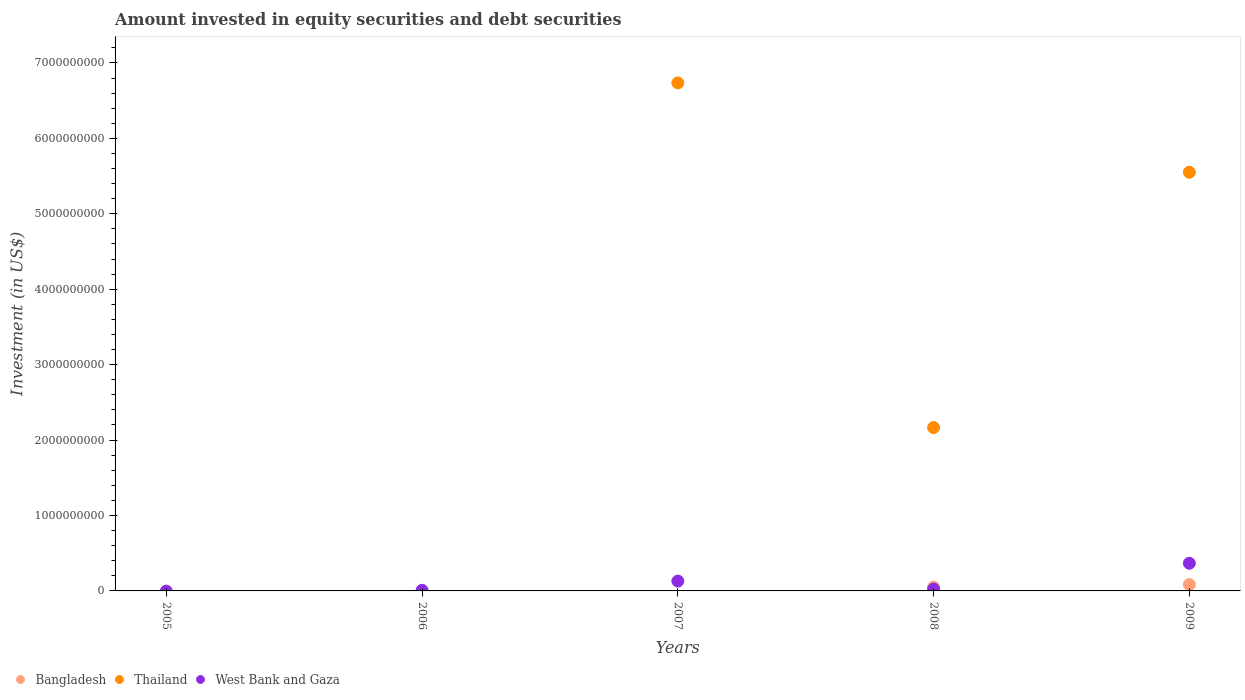How many different coloured dotlines are there?
Offer a terse response. 3. Is the number of dotlines equal to the number of legend labels?
Your answer should be compact. No. What is the amount invested in equity securities and debt securities in West Bank and Gaza in 2006?
Provide a succinct answer. 8.38e+06. Across all years, what is the maximum amount invested in equity securities and debt securities in Thailand?
Your answer should be very brief. 6.74e+09. What is the total amount invested in equity securities and debt securities in Bangladesh in the graph?
Your answer should be compact. 1.35e+08. What is the difference between the amount invested in equity securities and debt securities in Thailand in 2008 and that in 2009?
Your answer should be very brief. -3.39e+09. What is the difference between the amount invested in equity securities and debt securities in Bangladesh in 2005 and the amount invested in equity securities and debt securities in Thailand in 2008?
Ensure brevity in your answer.  -2.17e+09. What is the average amount invested in equity securities and debt securities in Bangladesh per year?
Provide a succinct answer. 2.71e+07. In the year 2008, what is the difference between the amount invested in equity securities and debt securities in West Bank and Gaza and amount invested in equity securities and debt securities in Bangladesh?
Offer a terse response. -2.59e+07. In how many years, is the amount invested in equity securities and debt securities in Bangladesh greater than 6000000000 US$?
Give a very brief answer. 0. What is the ratio of the amount invested in equity securities and debt securities in West Bank and Gaza in 2008 to that in 2009?
Your answer should be compact. 0.07. What is the difference between the highest and the second highest amount invested in equity securities and debt securities in Thailand?
Ensure brevity in your answer.  1.19e+09. What is the difference between the highest and the lowest amount invested in equity securities and debt securities in West Bank and Gaza?
Your answer should be very brief. 3.67e+08. In how many years, is the amount invested in equity securities and debt securities in West Bank and Gaza greater than the average amount invested in equity securities and debt securities in West Bank and Gaza taken over all years?
Provide a succinct answer. 2. Is it the case that in every year, the sum of the amount invested in equity securities and debt securities in Thailand and amount invested in equity securities and debt securities in West Bank and Gaza  is greater than the amount invested in equity securities and debt securities in Bangladesh?
Your answer should be very brief. No. How many dotlines are there?
Provide a succinct answer. 3. How many years are there in the graph?
Offer a very short reply. 5. Does the graph contain any zero values?
Give a very brief answer. Yes. Where does the legend appear in the graph?
Your response must be concise. Bottom left. How many legend labels are there?
Provide a short and direct response. 3. What is the title of the graph?
Make the answer very short. Amount invested in equity securities and debt securities. What is the label or title of the Y-axis?
Ensure brevity in your answer.  Investment (in US$). What is the Investment (in US$) in West Bank and Gaza in 2005?
Your answer should be compact. 0. What is the Investment (in US$) in Bangladesh in 2006?
Make the answer very short. 0. What is the Investment (in US$) in Thailand in 2006?
Your response must be concise. 0. What is the Investment (in US$) of West Bank and Gaza in 2006?
Your answer should be compact. 8.38e+06. What is the Investment (in US$) of Thailand in 2007?
Your response must be concise. 6.74e+09. What is the Investment (in US$) in West Bank and Gaza in 2007?
Offer a terse response. 1.31e+08. What is the Investment (in US$) of Bangladesh in 2008?
Your answer should be very brief. 5.06e+07. What is the Investment (in US$) of Thailand in 2008?
Provide a succinct answer. 2.17e+09. What is the Investment (in US$) in West Bank and Gaza in 2008?
Your response must be concise. 2.47e+07. What is the Investment (in US$) in Bangladesh in 2009?
Your answer should be compact. 8.47e+07. What is the Investment (in US$) in Thailand in 2009?
Provide a succinct answer. 5.55e+09. What is the Investment (in US$) of West Bank and Gaza in 2009?
Give a very brief answer. 3.67e+08. Across all years, what is the maximum Investment (in US$) of Bangladesh?
Offer a terse response. 8.47e+07. Across all years, what is the maximum Investment (in US$) in Thailand?
Provide a succinct answer. 6.74e+09. Across all years, what is the maximum Investment (in US$) in West Bank and Gaza?
Your response must be concise. 3.67e+08. Across all years, what is the minimum Investment (in US$) in Bangladesh?
Your answer should be very brief. 0. What is the total Investment (in US$) of Bangladesh in the graph?
Ensure brevity in your answer.  1.35e+08. What is the total Investment (in US$) in Thailand in the graph?
Give a very brief answer. 1.45e+1. What is the total Investment (in US$) of West Bank and Gaza in the graph?
Offer a very short reply. 5.31e+08. What is the difference between the Investment (in US$) in West Bank and Gaza in 2006 and that in 2007?
Give a very brief answer. -1.22e+08. What is the difference between the Investment (in US$) in West Bank and Gaza in 2006 and that in 2008?
Offer a terse response. -1.63e+07. What is the difference between the Investment (in US$) in West Bank and Gaza in 2006 and that in 2009?
Your answer should be very brief. -3.58e+08. What is the difference between the Investment (in US$) in Thailand in 2007 and that in 2008?
Your answer should be very brief. 4.57e+09. What is the difference between the Investment (in US$) of West Bank and Gaza in 2007 and that in 2008?
Provide a short and direct response. 1.06e+08. What is the difference between the Investment (in US$) in Thailand in 2007 and that in 2009?
Keep it short and to the point. 1.19e+09. What is the difference between the Investment (in US$) in West Bank and Gaza in 2007 and that in 2009?
Offer a terse response. -2.36e+08. What is the difference between the Investment (in US$) of Bangladesh in 2008 and that in 2009?
Your response must be concise. -3.41e+07. What is the difference between the Investment (in US$) of Thailand in 2008 and that in 2009?
Provide a short and direct response. -3.39e+09. What is the difference between the Investment (in US$) in West Bank and Gaza in 2008 and that in 2009?
Your answer should be compact. -3.42e+08. What is the difference between the Investment (in US$) in Thailand in 2007 and the Investment (in US$) in West Bank and Gaza in 2008?
Provide a short and direct response. 6.71e+09. What is the difference between the Investment (in US$) in Thailand in 2007 and the Investment (in US$) in West Bank and Gaza in 2009?
Keep it short and to the point. 6.37e+09. What is the difference between the Investment (in US$) of Bangladesh in 2008 and the Investment (in US$) of Thailand in 2009?
Ensure brevity in your answer.  -5.50e+09. What is the difference between the Investment (in US$) in Bangladesh in 2008 and the Investment (in US$) in West Bank and Gaza in 2009?
Your answer should be compact. -3.16e+08. What is the difference between the Investment (in US$) in Thailand in 2008 and the Investment (in US$) in West Bank and Gaza in 2009?
Ensure brevity in your answer.  1.80e+09. What is the average Investment (in US$) in Bangladesh per year?
Offer a very short reply. 2.71e+07. What is the average Investment (in US$) in Thailand per year?
Give a very brief answer. 2.89e+09. What is the average Investment (in US$) of West Bank and Gaza per year?
Make the answer very short. 1.06e+08. In the year 2007, what is the difference between the Investment (in US$) in Thailand and Investment (in US$) in West Bank and Gaza?
Offer a very short reply. 6.61e+09. In the year 2008, what is the difference between the Investment (in US$) of Bangladesh and Investment (in US$) of Thailand?
Make the answer very short. -2.12e+09. In the year 2008, what is the difference between the Investment (in US$) of Bangladesh and Investment (in US$) of West Bank and Gaza?
Offer a terse response. 2.59e+07. In the year 2008, what is the difference between the Investment (in US$) in Thailand and Investment (in US$) in West Bank and Gaza?
Ensure brevity in your answer.  2.14e+09. In the year 2009, what is the difference between the Investment (in US$) in Bangladesh and Investment (in US$) in Thailand?
Your answer should be compact. -5.47e+09. In the year 2009, what is the difference between the Investment (in US$) in Bangladesh and Investment (in US$) in West Bank and Gaza?
Provide a short and direct response. -2.82e+08. In the year 2009, what is the difference between the Investment (in US$) in Thailand and Investment (in US$) in West Bank and Gaza?
Provide a succinct answer. 5.18e+09. What is the ratio of the Investment (in US$) in West Bank and Gaza in 2006 to that in 2007?
Offer a terse response. 0.06. What is the ratio of the Investment (in US$) of West Bank and Gaza in 2006 to that in 2008?
Give a very brief answer. 0.34. What is the ratio of the Investment (in US$) in West Bank and Gaza in 2006 to that in 2009?
Ensure brevity in your answer.  0.02. What is the ratio of the Investment (in US$) in Thailand in 2007 to that in 2008?
Your response must be concise. 3.11. What is the ratio of the Investment (in US$) in West Bank and Gaza in 2007 to that in 2008?
Your response must be concise. 5.3. What is the ratio of the Investment (in US$) of Thailand in 2007 to that in 2009?
Offer a terse response. 1.21. What is the ratio of the Investment (in US$) in West Bank and Gaza in 2007 to that in 2009?
Your answer should be compact. 0.36. What is the ratio of the Investment (in US$) of Bangladesh in 2008 to that in 2009?
Keep it short and to the point. 0.6. What is the ratio of the Investment (in US$) in Thailand in 2008 to that in 2009?
Offer a very short reply. 0.39. What is the ratio of the Investment (in US$) in West Bank and Gaza in 2008 to that in 2009?
Make the answer very short. 0.07. What is the difference between the highest and the second highest Investment (in US$) in Thailand?
Keep it short and to the point. 1.19e+09. What is the difference between the highest and the second highest Investment (in US$) of West Bank and Gaza?
Keep it short and to the point. 2.36e+08. What is the difference between the highest and the lowest Investment (in US$) in Bangladesh?
Offer a terse response. 8.47e+07. What is the difference between the highest and the lowest Investment (in US$) of Thailand?
Provide a succinct answer. 6.74e+09. What is the difference between the highest and the lowest Investment (in US$) of West Bank and Gaza?
Provide a succinct answer. 3.67e+08. 